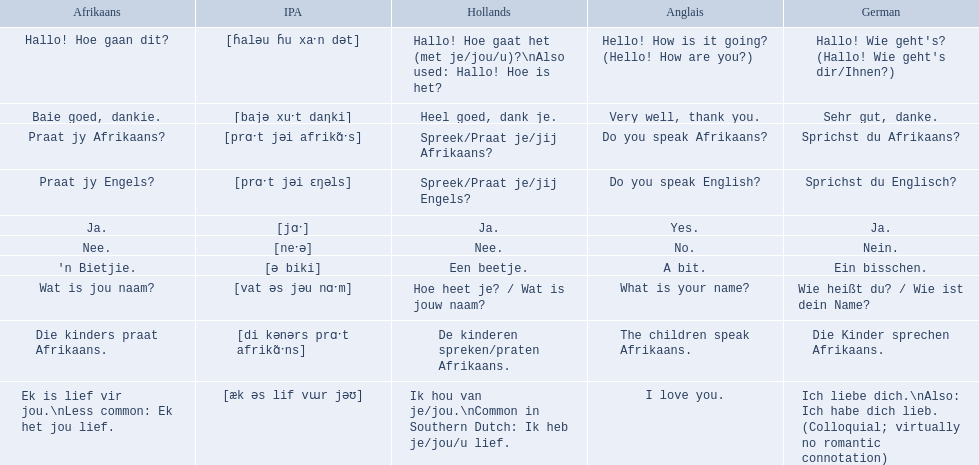What are the listed afrikaans phrases? Hallo! Hoe gaan dit?, Baie goed, dankie., Praat jy Afrikaans?, Praat jy Engels?, Ja., Nee., 'n Bietjie., Wat is jou naam?, Die kinders praat Afrikaans., Ek is lief vir jou.\nLess common: Ek het jou lief. Which is die kinders praat afrikaans? Die kinders praat Afrikaans. What is its german translation? Die Kinder sprechen Afrikaans. 